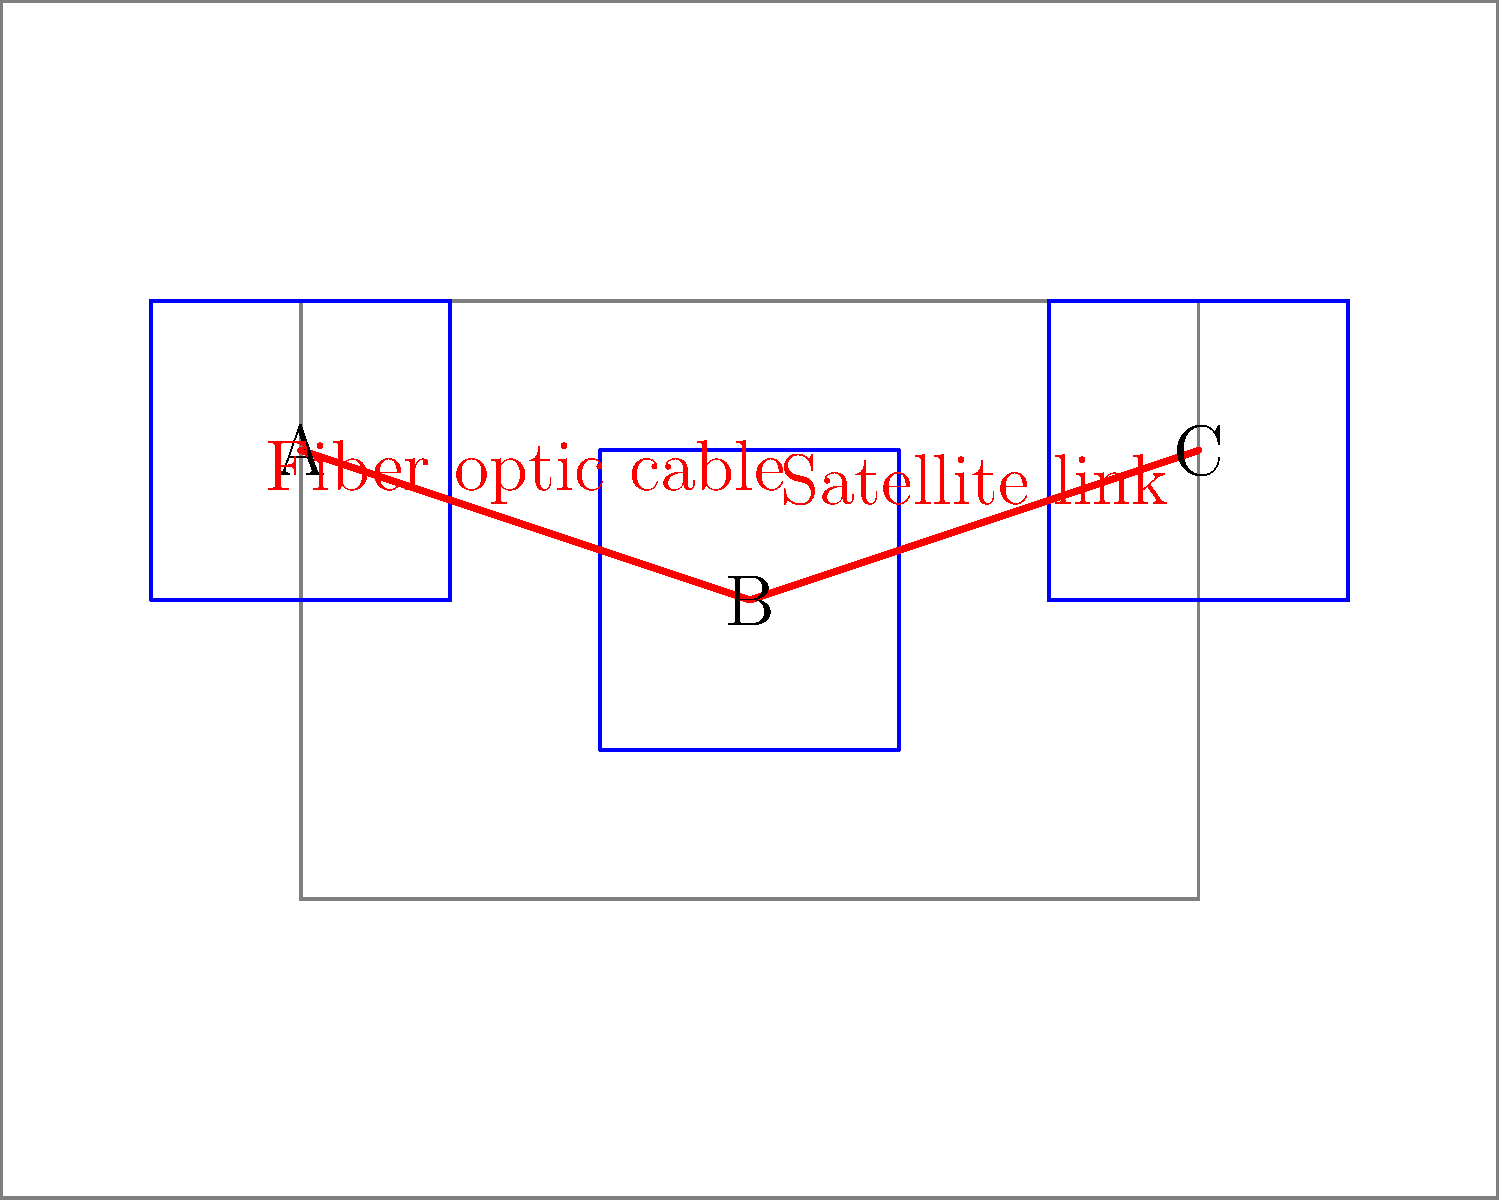In the given world map representation, which country serves as the central hub for telecommunications infrastructure, connecting the other two countries? To determine the central hub for telecommunications infrastructure, we need to analyze the network connections shown in the map:

1. The map shows three countries: A, B, and C.
2. There are two types of connections represented:
   a. A fiber optic cable connecting country A to country B
   b. A satellite link connecting country B to country C
3. Country B is the only country connected to both other countries.
4. Country A and country C are not directly connected to each other.
5. All communication between country A and country C must pass through country B.

Therefore, country B serves as the central hub for telecommunications infrastructure, connecting the other two countries (A and C).
Answer: B 